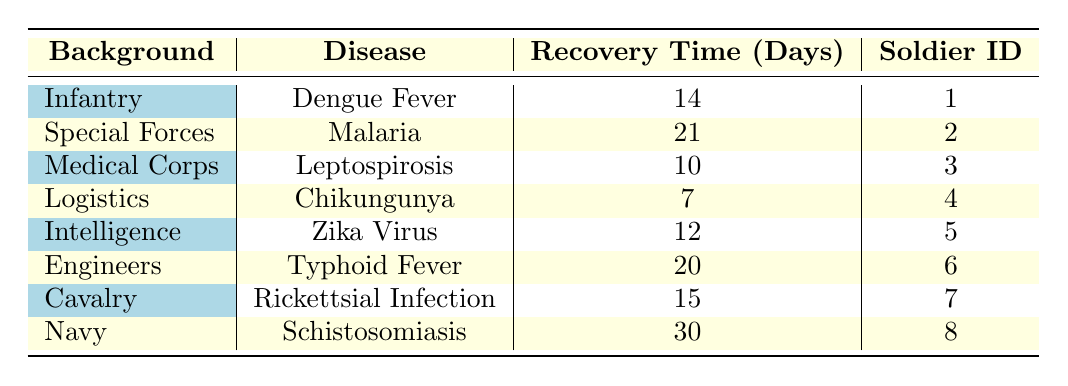What is the recovery time for the soldier with the shortest recovery time? The shortest recovery time in the table is 7 days, which is associated with Chikungunya and soldier ID 4 under the Logistics background.
Answer: 7 days Which disease has the longest recovery time? The longest recovery time in the table is 30 days, attributed to Schistosomiasis and soldier ID 8 in the Navy background.
Answer: 30 days Is the recovery time for Malaria greater than for Zika Virus? The recovery time for Malaria is 21 days, while Zika Virus has a recovery time of 12 days. Therefore, 21 days is greater than 12 days.
Answer: Yes What is the average recovery time for soldiers in the Infantry and Special Forces backgrounds? For Infantry (Dengue Fever, 14 days) and Special Forces (Malaria, 21 days), the average is calculated as (14 + 21) / 2 = 17.5 days.
Answer: 17.5 days Which background has a recovery time of exactly 20 days? The background that has a 20-day recovery time is Engineers, associated with Typhoid Fever and soldier ID 6.
Answer: Engineers What is the total recovery time for all soldiers from the Medical Corps and Intelligence backgrounds? The total recovery time is the sum of Leptospirosis (10 days) and Zika Virus (12 days), which equals 10 + 12 = 22 days.
Answer: 22 days Is there a soldier with a recovery time of 15 days? Yes, there is a soldier (soldier ID 7) from the Cavalry background recovering from Rickettsial Infection, which takes 15 days.
Answer: Yes What is the difference in recovery time between the disease with the shortest recovery time and the disease with the longest recovery time? The shortest recovery time is 7 days (Chikungunya) and the longest is 30 days (Schistosomiasis). The difference is 30 - 7 = 23 days.
Answer: 23 days 